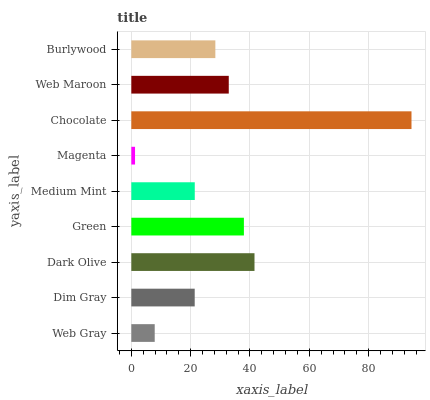Is Magenta the minimum?
Answer yes or no. Yes. Is Chocolate the maximum?
Answer yes or no. Yes. Is Dim Gray the minimum?
Answer yes or no. No. Is Dim Gray the maximum?
Answer yes or no. No. Is Dim Gray greater than Web Gray?
Answer yes or no. Yes. Is Web Gray less than Dim Gray?
Answer yes or no. Yes. Is Web Gray greater than Dim Gray?
Answer yes or no. No. Is Dim Gray less than Web Gray?
Answer yes or no. No. Is Burlywood the high median?
Answer yes or no. Yes. Is Burlywood the low median?
Answer yes or no. Yes. Is Chocolate the high median?
Answer yes or no. No. Is Web Gray the low median?
Answer yes or no. No. 